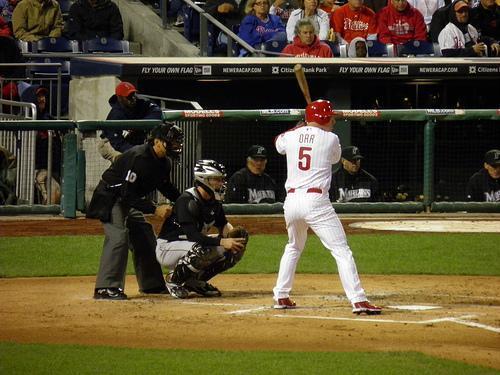How many people in the image can be clearly seen wearing mariners jerseys?
Give a very brief answer. 3. 